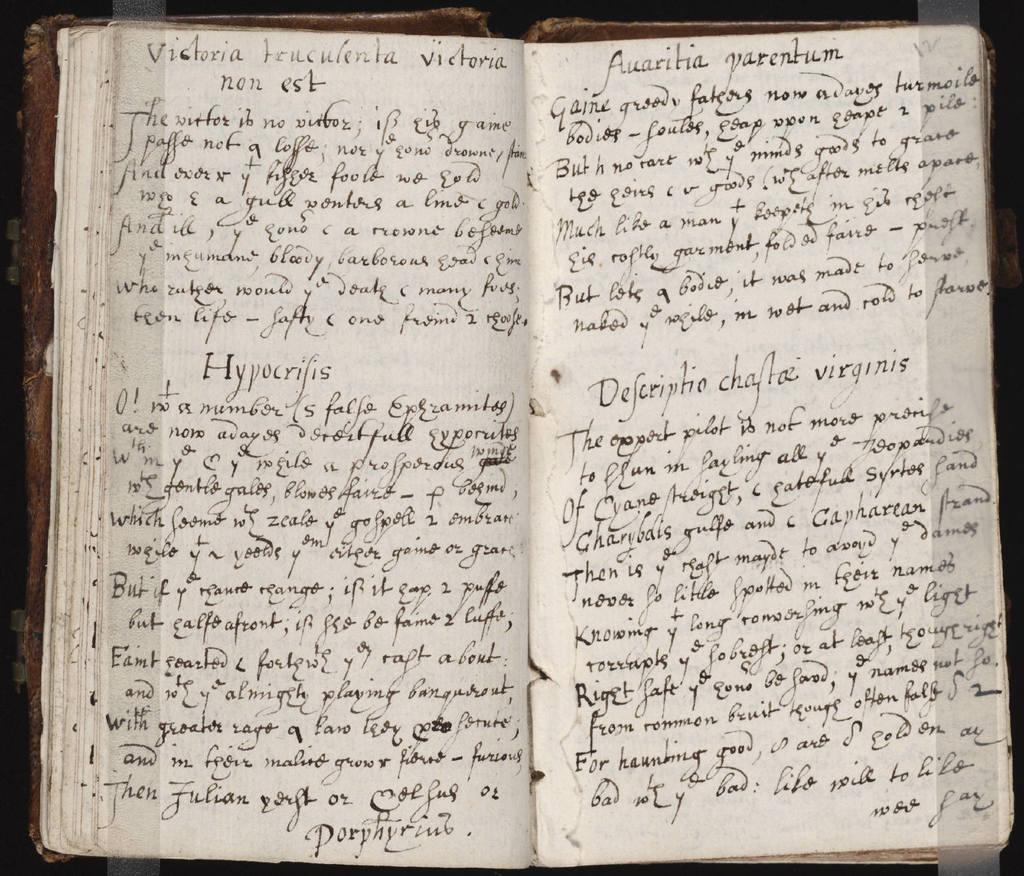What is the title of the second section on the first page?
Ensure brevity in your answer.  Hypocrifis. 